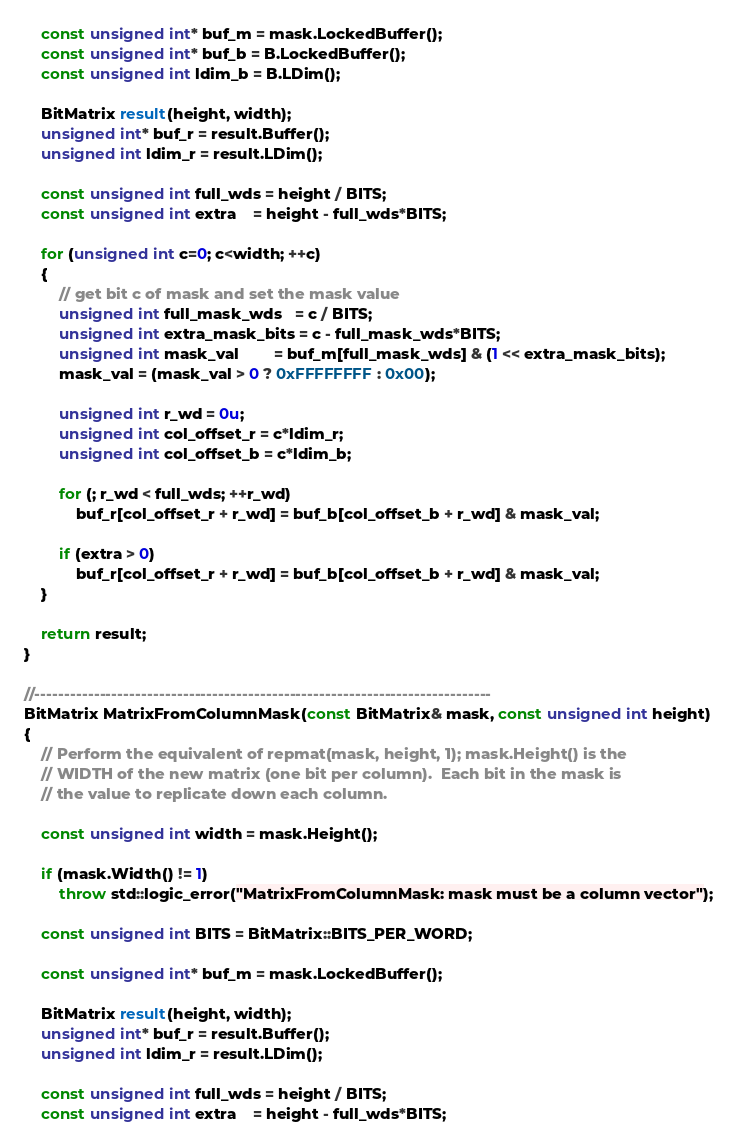Convert code to text. <code><loc_0><loc_0><loc_500><loc_500><_C++_>
    const unsigned int* buf_m = mask.LockedBuffer();
    const unsigned int* buf_b = B.LockedBuffer();
    const unsigned int ldim_b = B.LDim();

    BitMatrix result(height, width);
    unsigned int* buf_r = result.Buffer();
    unsigned int ldim_r = result.LDim();

    const unsigned int full_wds = height / BITS;
    const unsigned int extra    = height - full_wds*BITS;

    for (unsigned int c=0; c<width; ++c)
    {
        // get bit c of mask and set the mask value
        unsigned int full_mask_wds   = c / BITS;
        unsigned int extra_mask_bits = c - full_mask_wds*BITS;
        unsigned int mask_val        = buf_m[full_mask_wds] & (1 << extra_mask_bits);
        mask_val = (mask_val > 0 ? 0xFFFFFFFF : 0x00);

        unsigned int r_wd = 0u;
        unsigned int col_offset_r = c*ldim_r;
        unsigned int col_offset_b = c*ldim_b;

        for (; r_wd < full_wds; ++r_wd)
            buf_r[col_offset_r + r_wd] = buf_b[col_offset_b + r_wd] & mask_val;

        if (extra > 0)
            buf_r[col_offset_r + r_wd] = buf_b[col_offset_b + r_wd] & mask_val;
    }

    return result;
}

//-----------------------------------------------------------------------------
BitMatrix MatrixFromColumnMask(const BitMatrix& mask, const unsigned int height)
{
    // Perform the equivalent of repmat(mask, height, 1); mask.Height() is the
    // WIDTH of the new matrix (one bit per column).  Each bit in the mask is 
    // the value to replicate down each column.

    const unsigned int width = mask.Height();

    if (mask.Width() != 1)
        throw std::logic_error("MatrixFromColumnMask: mask must be a column vector");
    
    const unsigned int BITS = BitMatrix::BITS_PER_WORD;

    const unsigned int* buf_m = mask.LockedBuffer();

    BitMatrix result(height, width);
    unsigned int* buf_r = result.Buffer();
    unsigned int ldim_r = result.LDim();

    const unsigned int full_wds = height / BITS;
    const unsigned int extra    = height - full_wds*BITS;
</code> 